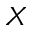<formula> <loc_0><loc_0><loc_500><loc_500>X</formula> 